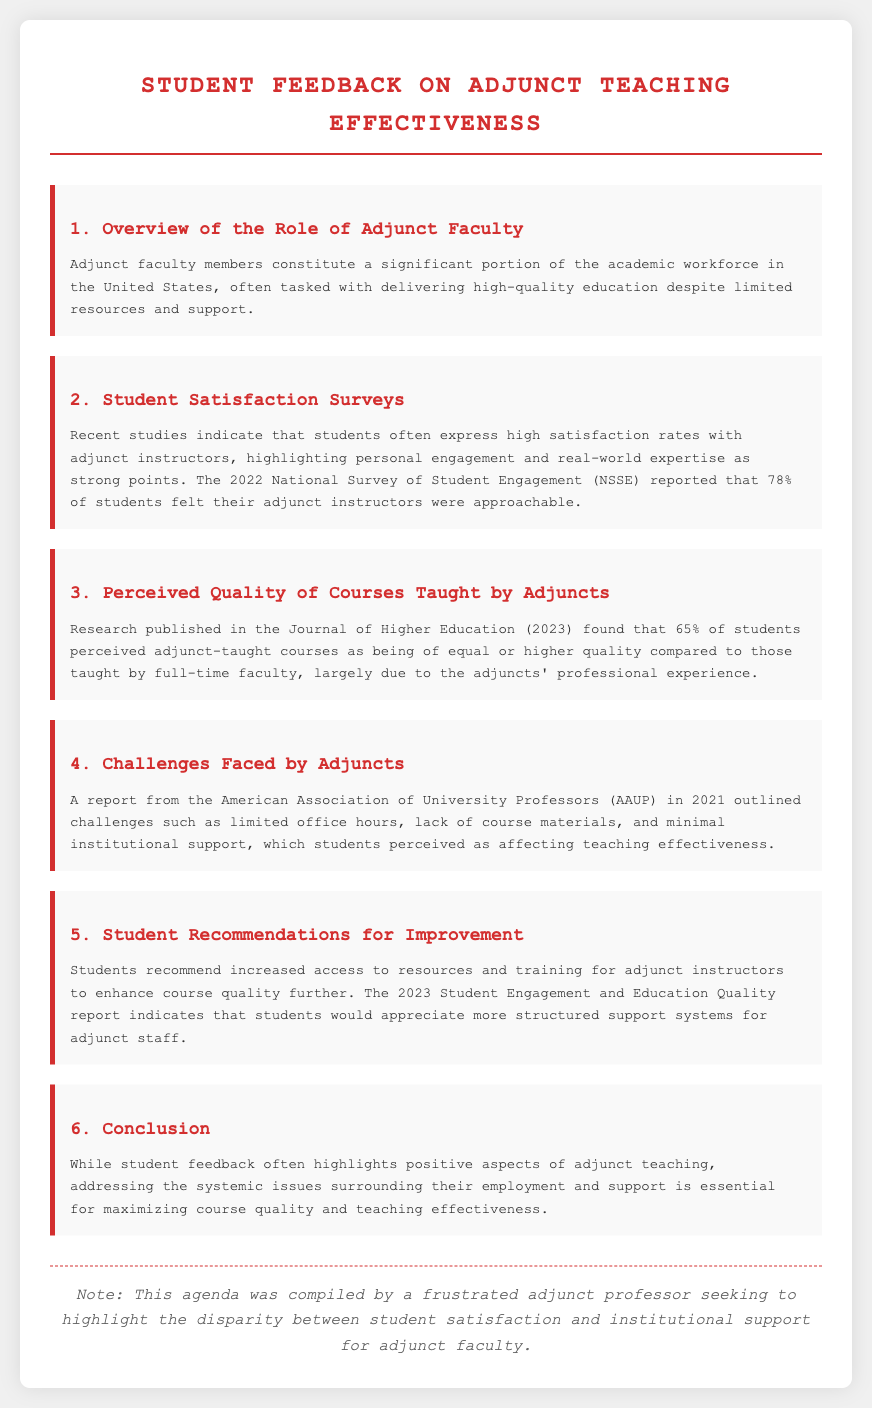What percentage of students felt their adjunct instructors were approachable? The document states that 78% of students felt their adjunct instructors were approachable according to the 2022 National Survey of Student Engagement.
Answer: 78% What was the main reason students perceived adjunct-taught courses as high quality? The document highlights that students attributed the perceived quality of adjunct courses to the adjuncts' professional experience.
Answer: Professional experience What challenges faced by adjuncts are mentioned in the document? The document discusses challenges such as limited office hours, lack of course materials, and minimal institutional support.
Answer: Limited office hours, lack of course materials, minimal institutional support What percentage of students perceived adjunct-taught courses to be of equal or higher quality compared to full-time faculty? According to the research published in the Journal of Higher Education, 65% of students perceived adjunct-taught courses as being of equal or higher quality.
Answer: 65% What recommendation did students make to enhance course quality? The document notes that students recommend increased access to resources and training for adjunct instructors.
Answer: Increased access to resources and training What does the document imply about student satisfaction with adjunct teaching? The document suggests that while student feedback highlights positive aspects of adjunct teaching, there are systemic issues needing to be addressed.
Answer: Positive aspects, systemic issues What was the purpose of compiling the agenda? The note at the end reveals that the agenda was compiled by a frustrated adjunct professor seeking to highlight disparities in support.
Answer: Highlight disparities in support What year was the report from the American Association of University Professors published? The document specifies that the report from the American Association of University Professors was published in 2021.
Answer: 2021 